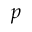<formula> <loc_0><loc_0><loc_500><loc_500>p</formula> 